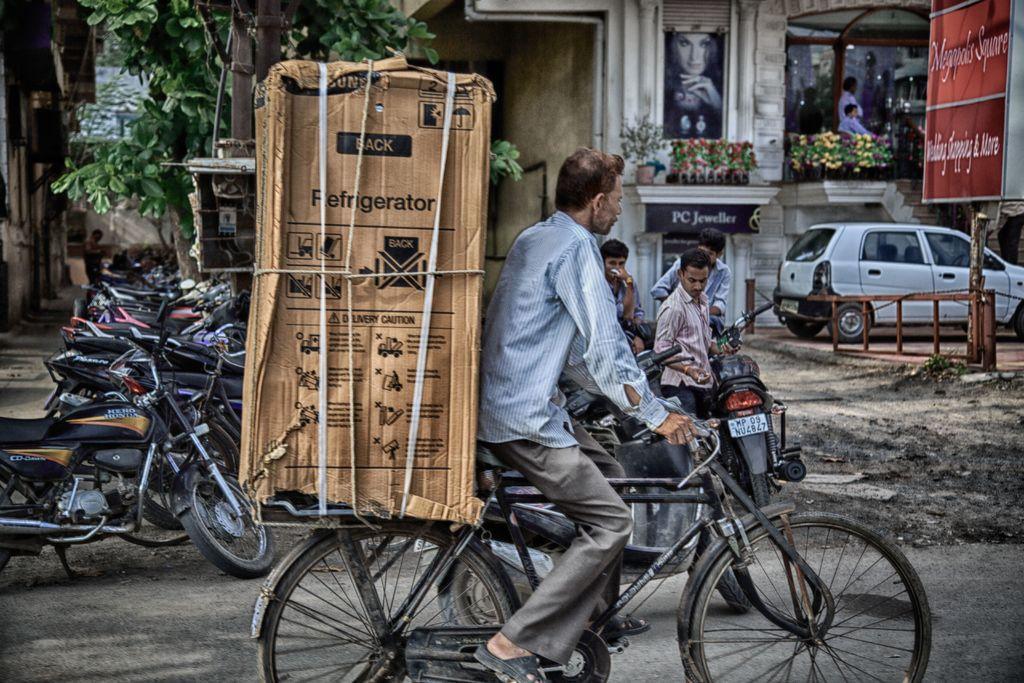Please provide a concise description of this image. In this picture there is a man cycling a bicycle with a refrigerator box behind him. In the background there are some vehicles parked and some of them was standing here. We can observe some trees and buildings here. 